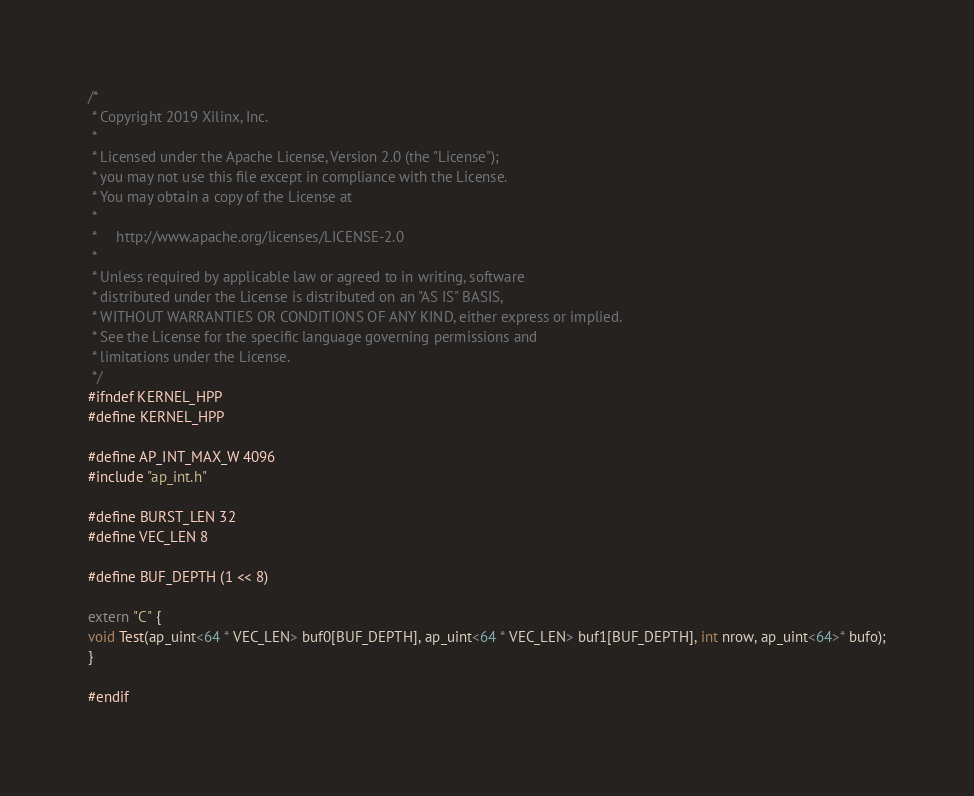<code> <loc_0><loc_0><loc_500><loc_500><_C++_>/*
 * Copyright 2019 Xilinx, Inc.
 *
 * Licensed under the Apache License, Version 2.0 (the "License");
 * you may not use this file except in compliance with the License.
 * You may obtain a copy of the License at
 *
 *     http://www.apache.org/licenses/LICENSE-2.0
 *
 * Unless required by applicable law or agreed to in writing, software
 * distributed under the License is distributed on an "AS IS" BASIS,
 * WITHOUT WARRANTIES OR CONDITIONS OF ANY KIND, either express or implied.
 * See the License for the specific language governing permissions and
 * limitations under the License.
 */
#ifndef KERNEL_HPP
#define KERNEL_HPP

#define AP_INT_MAX_W 4096
#include "ap_int.h"

#define BURST_LEN 32
#define VEC_LEN 8

#define BUF_DEPTH (1 << 8)

extern "C" {
void Test(ap_uint<64 * VEC_LEN> buf0[BUF_DEPTH], ap_uint<64 * VEC_LEN> buf1[BUF_DEPTH], int nrow, ap_uint<64>* bufo);
}

#endif
</code> 